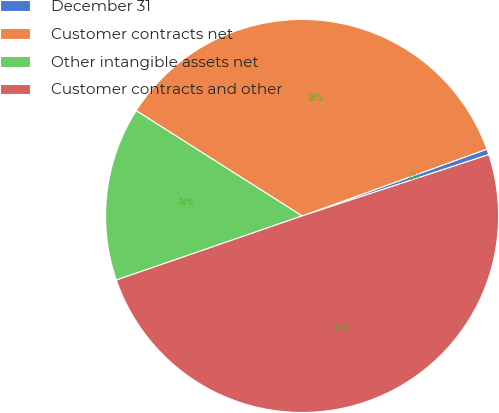<chart> <loc_0><loc_0><loc_500><loc_500><pie_chart><fcel>December 31<fcel>Customer contracts net<fcel>Other intangible assets net<fcel>Customer contracts and other<nl><fcel>0.47%<fcel>35.48%<fcel>14.29%<fcel>49.77%<nl></chart> 